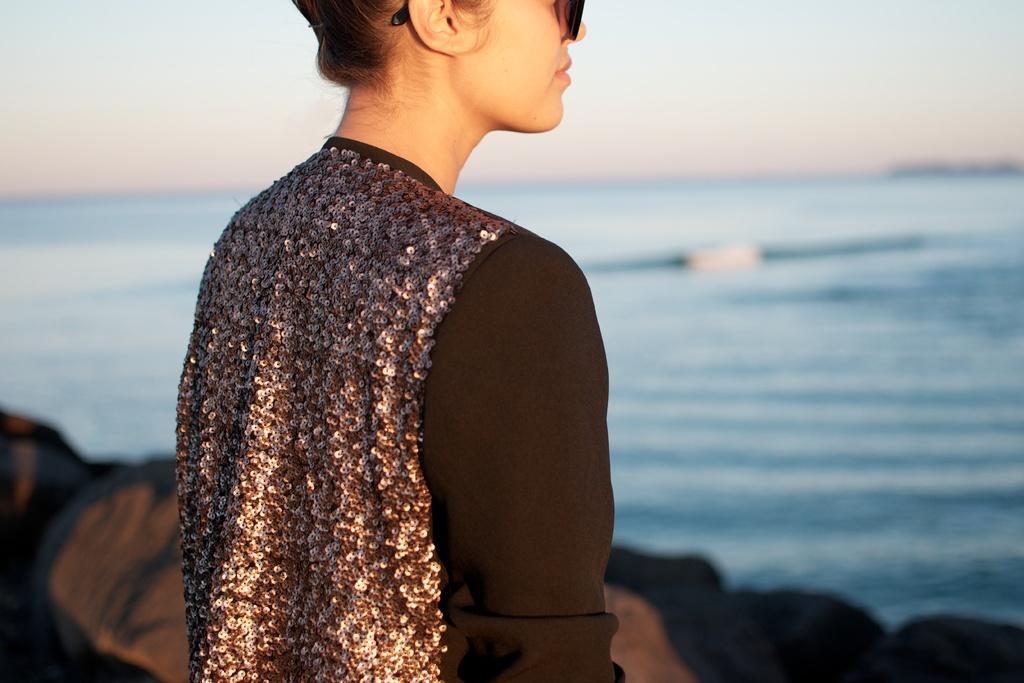In one or two sentences, can you explain what this image depicts? In this image we can see a woman standing. On the backside we can see the rocks, a large water body and the sky. 